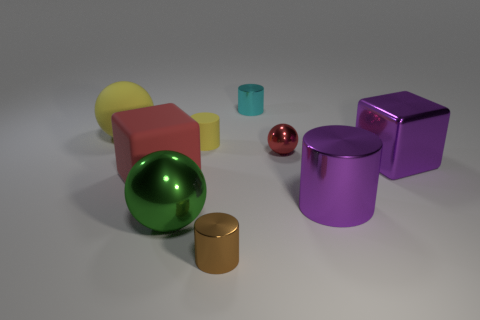There is a small cyan thing; is it the same shape as the yellow matte object that is in front of the big yellow rubber sphere?
Offer a very short reply. Yes. What is the size of the metal object that is both behind the red cube and left of the red metallic thing?
Your answer should be very brief. Small. How many tiny red metal blocks are there?
Provide a short and direct response. 0. What is the material of the ball that is the same size as the matte cylinder?
Provide a short and direct response. Metal. Are there any red matte balls that have the same size as the brown shiny cylinder?
Provide a succinct answer. No. There is a ball that is behind the small red metal ball; is its color the same as the cube right of the cyan object?
Your answer should be compact. No. What number of metal objects are either tiny red spheres or brown cylinders?
Make the answer very short. 2. There is a tiny cylinder that is behind the yellow rubber object that is right of the big red rubber block; how many small metallic things are on the right side of it?
Offer a terse response. 1. The cyan thing that is the same material as the big green object is what size?
Your answer should be very brief. Small. How many matte blocks have the same color as the tiny ball?
Keep it short and to the point. 1. 